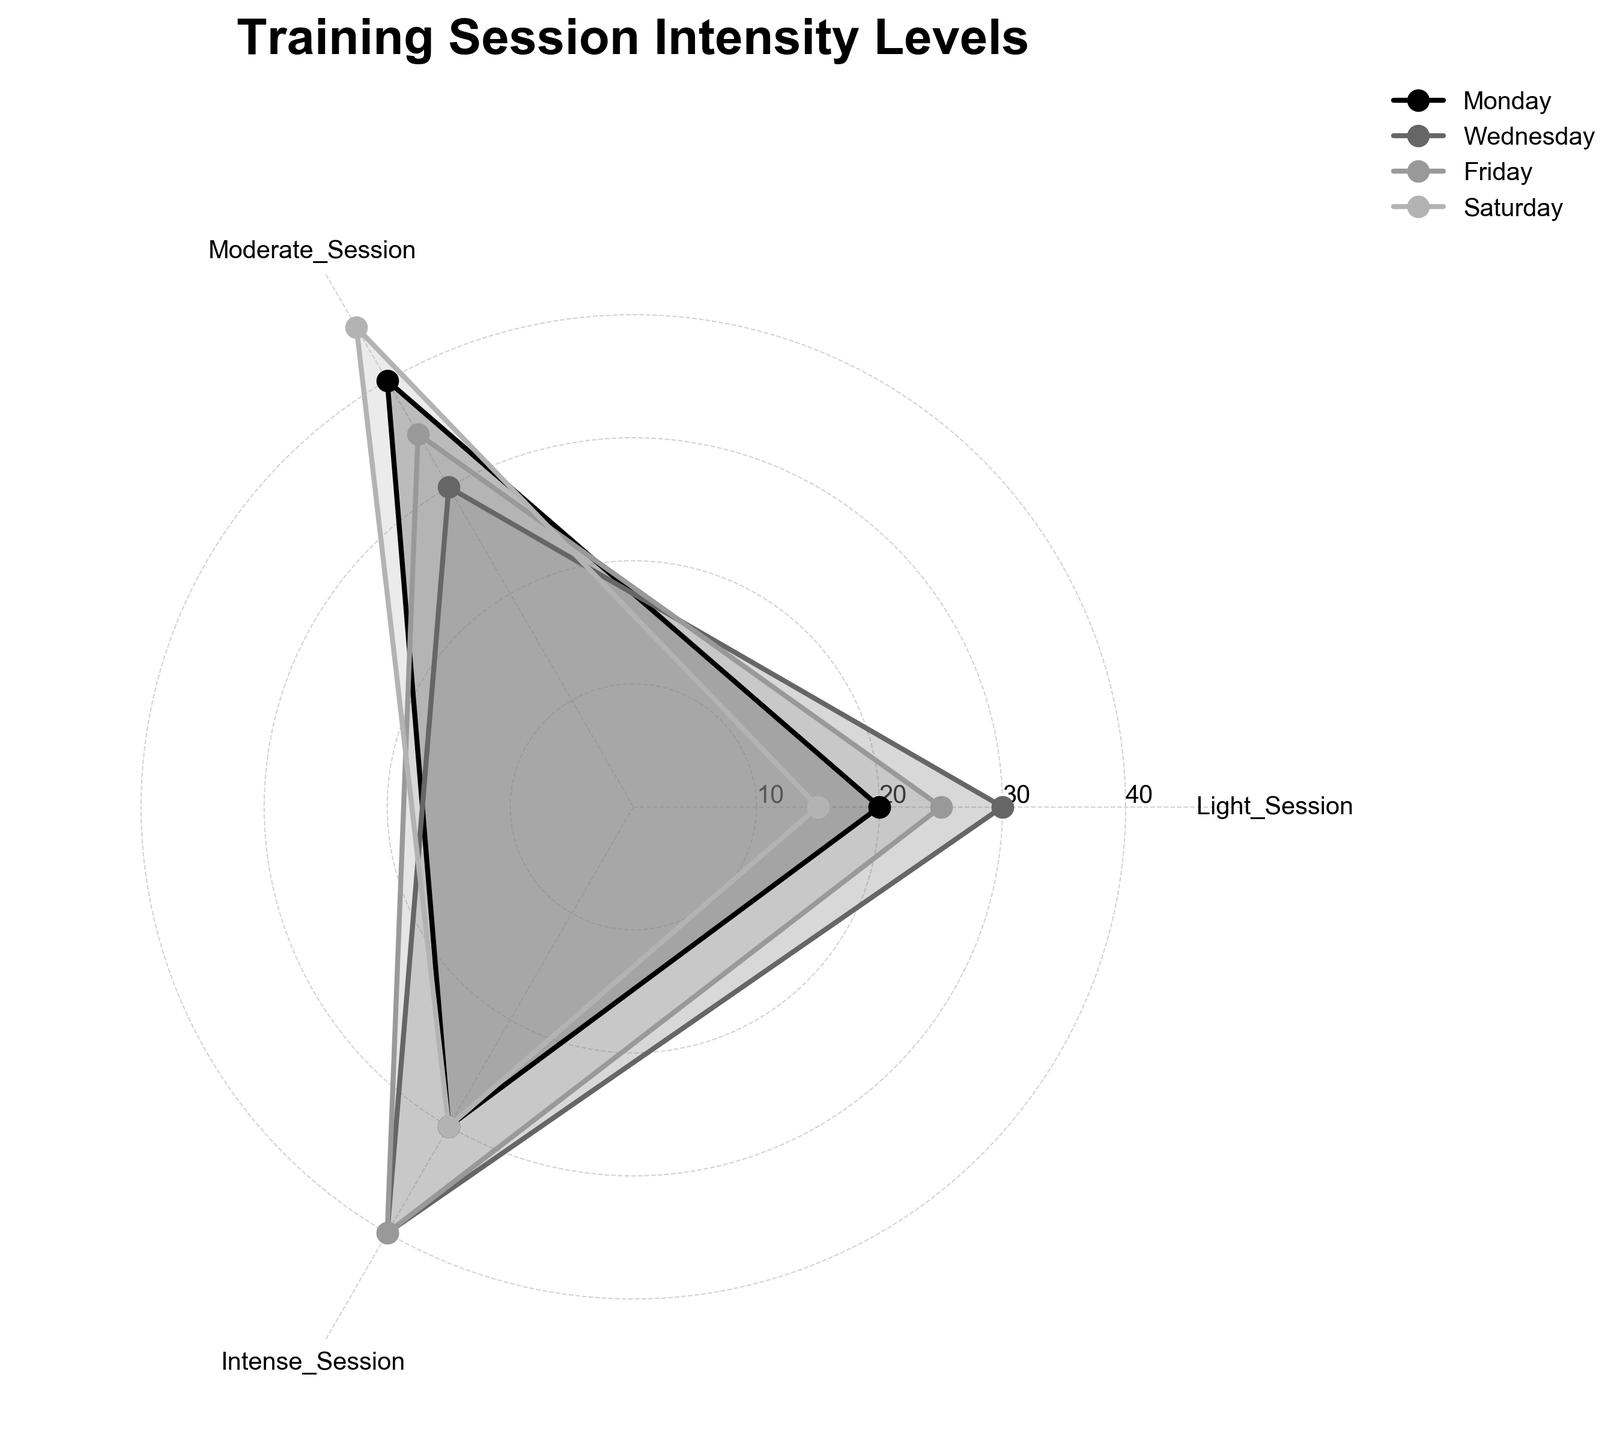What's the title of the plot? The title of the plot is usually placed at the top of the chart. It's written in a larger, bold font and is centered.
Answer: Training Session Intensity Levels How many categories are displayed in the plot? The plot shows three categories (Light_Session, Moderate_Session, Intense_Session) as indicated by the labels around the chart.
Answer: 3 Which training day has the highest intense session? By looking at the area corresponding to each day's intense session, the longest bar indicates the maximum value which is for Wednesday and Friday.
Answer: Wednesday and Friday On which days is the distribution of session types equal for the moderate and intense sessions? Checking the length of the segments for moderate and intense sessions reveals that Wednesday has equal values (30 for each).
Answer: Wednesday Which day has the least variation between session types? To find the least variation, look for the day where all session types are closest in magnitude. Saturday has light and intense sessions with 15 and 30 and only moderate is 45.
Answer: Saturday What is the average value of moderate sessions across all training days? Moderate sessions sums up to (40 + 30 + 35 + 45). Divide the sum by the number of days (4). That is (40 + 30 + 35 + 45) / 4 = 37.5
Answer: 37.5 Comparing Friday and Monday, which has more light sessions? The length of the segment for light sessions shows Friday has 25 and Monday has 20. Therefore, Friday has more light sessions.
Answer: Friday What is the combined value of intense sessions on Monday and Wednesday? Sum the intense sessions: Monday (30) plus Wednesday (40), which is 30 + 40 = 70.
Answer: 70 Which category shows the most significant variation across different training days? Evaluate by looking for the category with the greatest spread in lengths. Light sessions range from 15 to 30, moderate from 30 to 45, intense from 30 to 40. Light sessions have the most variation.
Answer: Light_Session Based on the plot, which training day has evenly distributed sessions? The plot shows Monday has fairly balanced values for light (20), moderate (40), and intense (30) sessions, indicating an even distribution.
Answer: Monday 